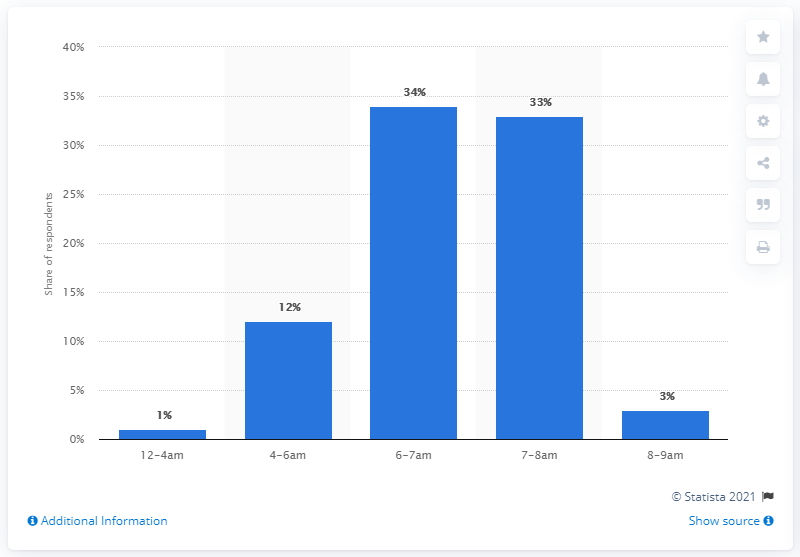Point out several critical features in this image. In 2013, the typical wake up time in the UK was around 6-7am. 